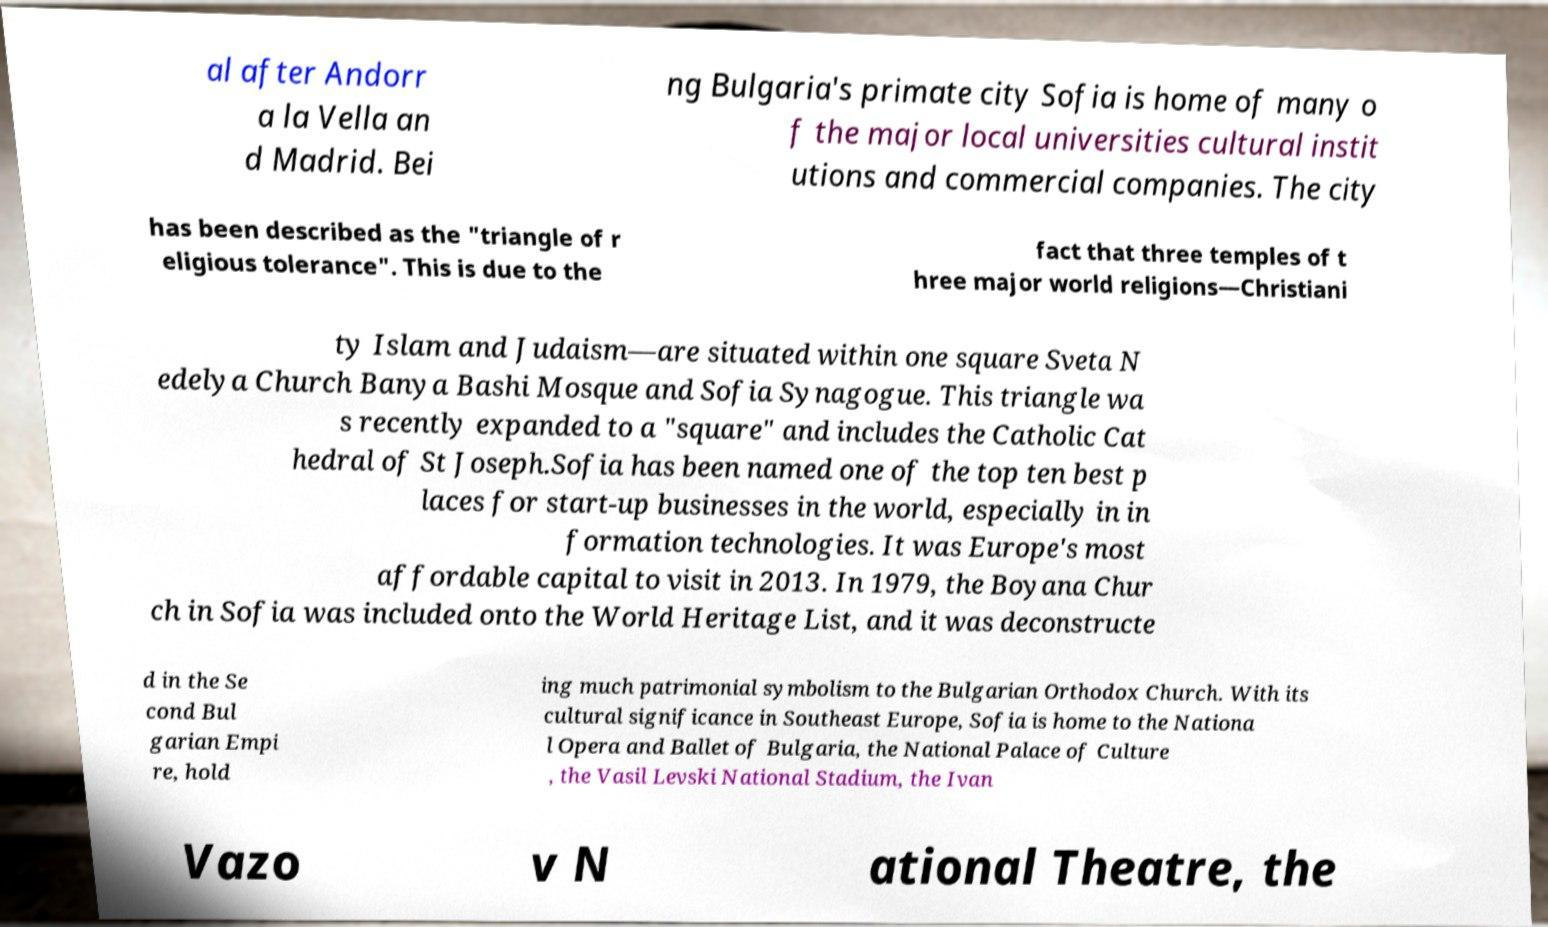Can you read and provide the text displayed in the image?This photo seems to have some interesting text. Can you extract and type it out for me? al after Andorr a la Vella an d Madrid. Bei ng Bulgaria's primate city Sofia is home of many o f the major local universities cultural instit utions and commercial companies. The city has been described as the "triangle of r eligious tolerance". This is due to the fact that three temples of t hree major world religions—Christiani ty Islam and Judaism—are situated within one square Sveta N edelya Church Banya Bashi Mosque and Sofia Synagogue. This triangle wa s recently expanded to a "square" and includes the Catholic Cat hedral of St Joseph.Sofia has been named one of the top ten best p laces for start-up businesses in the world, especially in in formation technologies. It was Europe's most affordable capital to visit in 2013. In 1979, the Boyana Chur ch in Sofia was included onto the World Heritage List, and it was deconstructe d in the Se cond Bul garian Empi re, hold ing much patrimonial symbolism to the Bulgarian Orthodox Church. With its cultural significance in Southeast Europe, Sofia is home to the Nationa l Opera and Ballet of Bulgaria, the National Palace of Culture , the Vasil Levski National Stadium, the Ivan Vazo v N ational Theatre, the 